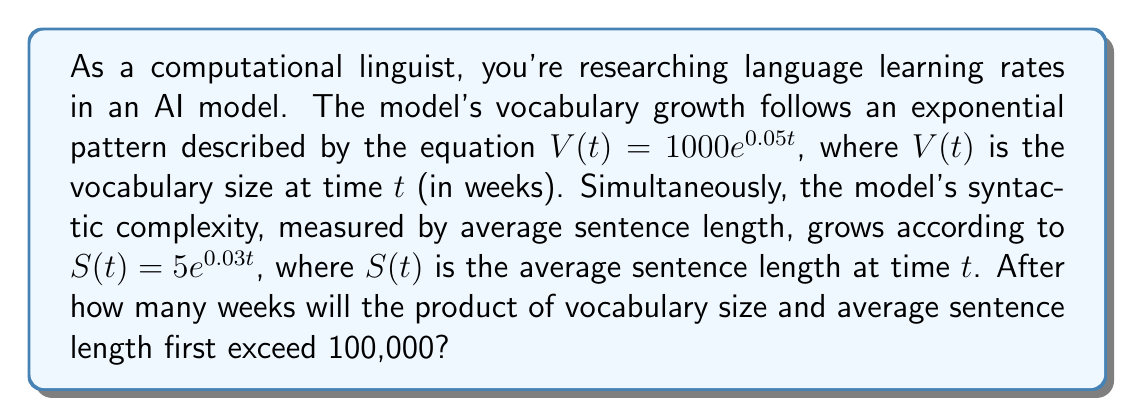Can you solve this math problem? Let's approach this step-by-step:

1) We need to find $t$ where $V(t) \cdot S(t) > 100,000$

2) Let's set up the inequality:
   $$(1000e^{0.05t}) \cdot (5e^{0.03t}) > 100,000$$

3) Simplify the left side:
   $$5000e^{0.08t} > 100,000$$

4) Take the natural log of both sides:
   $$\ln(5000) + 0.08t > \ln(100,000)$$

5) Simplify:
   $$8.5172 + 0.08t > 11.5129$$

6) Subtract 8.5172 from both sides:
   $$0.08t > 2.9957$$

7) Divide both sides by 0.08:
   $$t > 37.4463$$

8) Since we're asked for the number of weeks, and this needs to be an integer, we round up to the next whole number.
Answer: The product of vocabulary size and average sentence length will first exceed 100,000 after 38 weeks. 